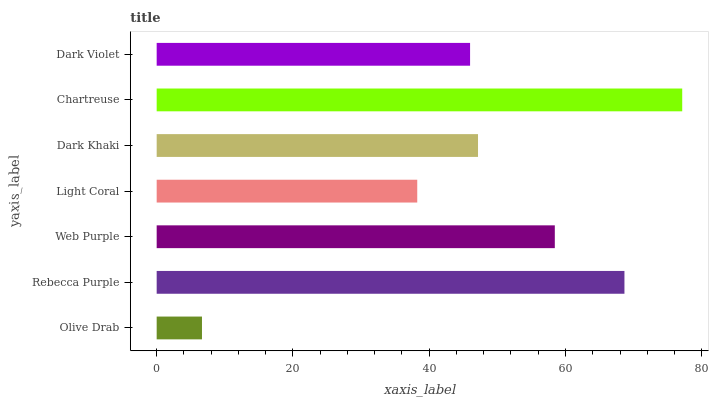Is Olive Drab the minimum?
Answer yes or no. Yes. Is Chartreuse the maximum?
Answer yes or no. Yes. Is Rebecca Purple the minimum?
Answer yes or no. No. Is Rebecca Purple the maximum?
Answer yes or no. No. Is Rebecca Purple greater than Olive Drab?
Answer yes or no. Yes. Is Olive Drab less than Rebecca Purple?
Answer yes or no. Yes. Is Olive Drab greater than Rebecca Purple?
Answer yes or no. No. Is Rebecca Purple less than Olive Drab?
Answer yes or no. No. Is Dark Khaki the high median?
Answer yes or no. Yes. Is Dark Khaki the low median?
Answer yes or no. Yes. Is Dark Violet the high median?
Answer yes or no. No. Is Chartreuse the low median?
Answer yes or no. No. 